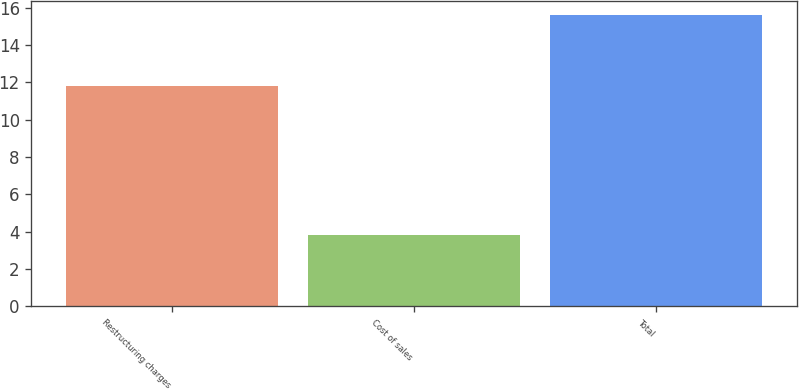Convert chart to OTSL. <chart><loc_0><loc_0><loc_500><loc_500><bar_chart><fcel>Restructuring charges<fcel>Cost of sales<fcel>Total<nl><fcel>11.8<fcel>3.8<fcel>15.6<nl></chart> 